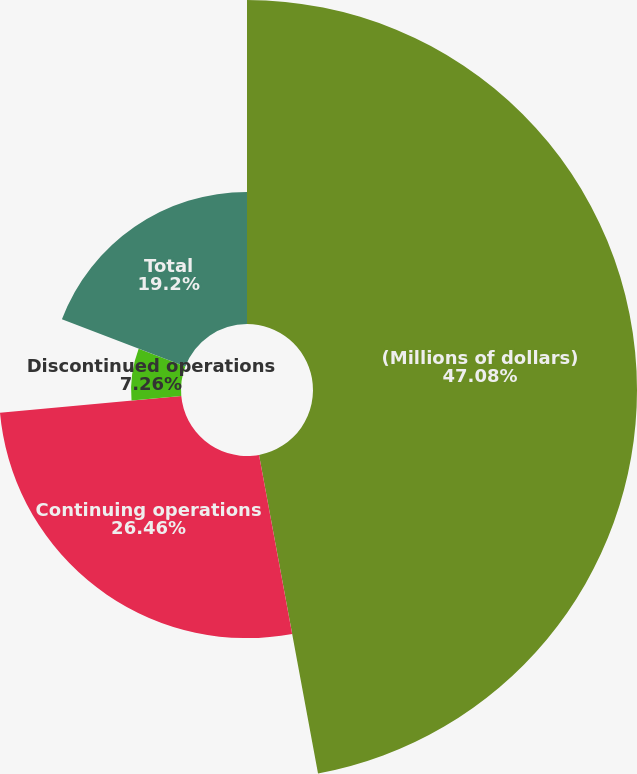Convert chart. <chart><loc_0><loc_0><loc_500><loc_500><pie_chart><fcel>(Millions of dollars)<fcel>Continuing operations<fcel>Discontinued operations<fcel>Total<nl><fcel>47.09%<fcel>26.46%<fcel>7.26%<fcel>19.2%<nl></chart> 